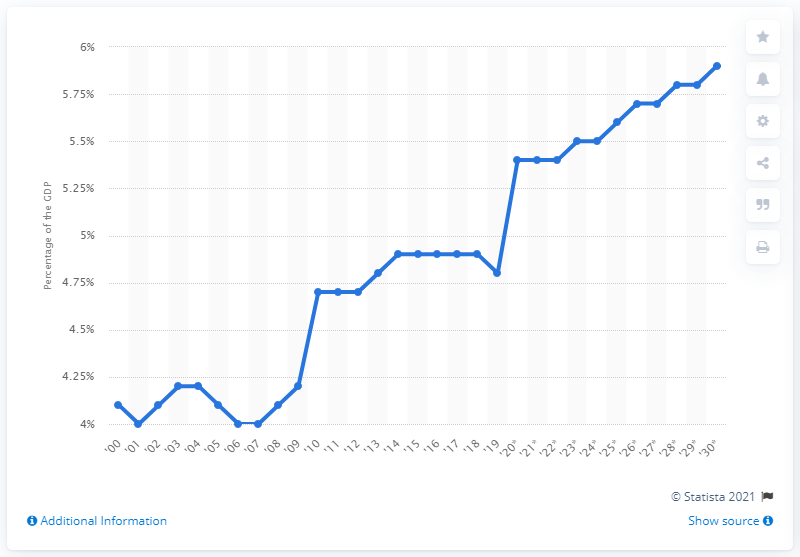Outline some significant characteristics in this image. In 2030, social security outlays are estimated to account for 5.9% of the projected U.S. GDP. 